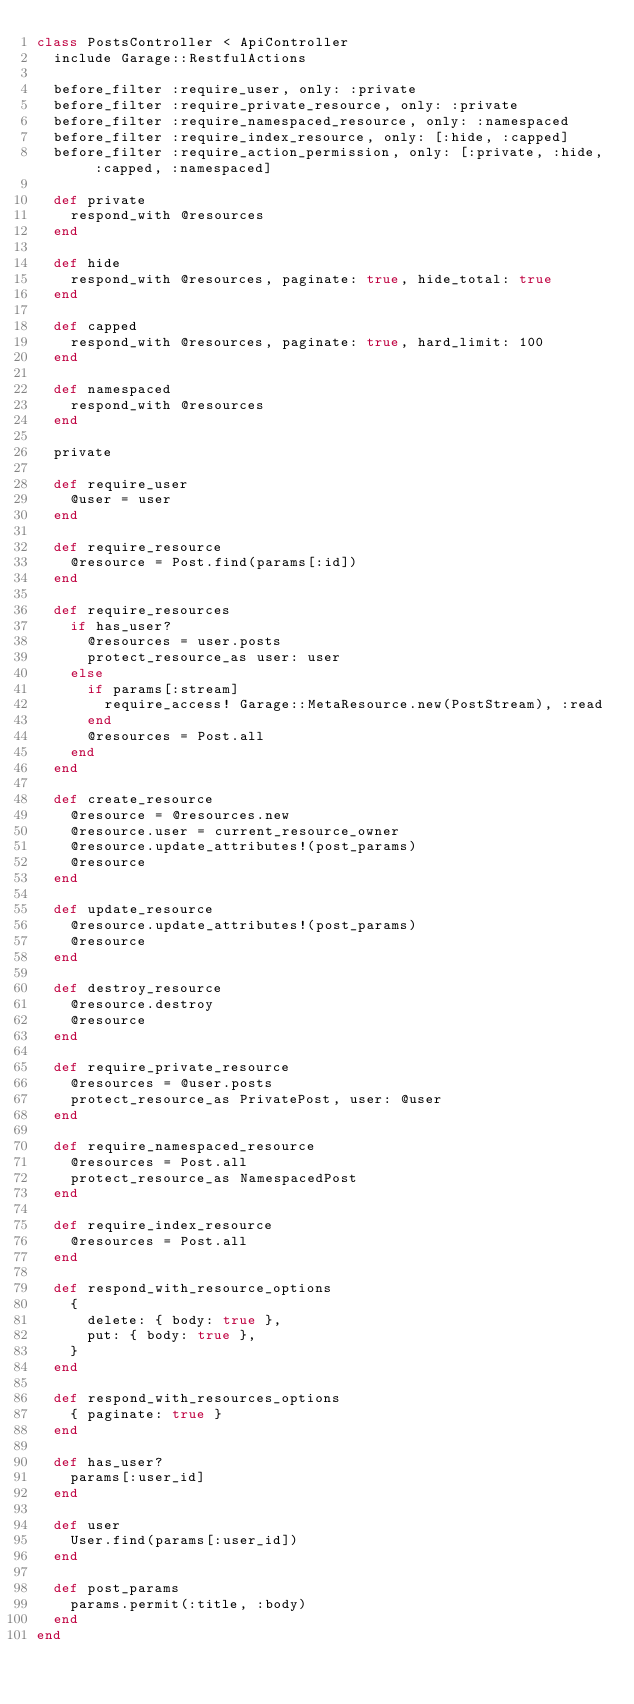Convert code to text. <code><loc_0><loc_0><loc_500><loc_500><_Ruby_>class PostsController < ApiController
  include Garage::RestfulActions

  before_filter :require_user, only: :private
  before_filter :require_private_resource, only: :private
  before_filter :require_namespaced_resource, only: :namespaced
  before_filter :require_index_resource, only: [:hide, :capped]
  before_filter :require_action_permission, only: [:private, :hide, :capped, :namespaced]

  def private
    respond_with @resources
  end

  def hide
    respond_with @resources, paginate: true, hide_total: true
  end

  def capped
    respond_with @resources, paginate: true, hard_limit: 100
  end

  def namespaced
    respond_with @resources
  end

  private

  def require_user
    @user = user
  end

  def require_resource
    @resource = Post.find(params[:id])
  end

  def require_resources
    if has_user?
      @resources = user.posts
      protect_resource_as user: user
    else
      if params[:stream]
        require_access! Garage::MetaResource.new(PostStream), :read
      end
      @resources = Post.all
    end
  end

  def create_resource
    @resource = @resources.new
    @resource.user = current_resource_owner
    @resource.update_attributes!(post_params)
    @resource
  end

  def update_resource
    @resource.update_attributes!(post_params)
    @resource
  end

  def destroy_resource
    @resource.destroy
    @resource
  end

  def require_private_resource
    @resources = @user.posts
    protect_resource_as PrivatePost, user: @user
  end

  def require_namespaced_resource
    @resources = Post.all
    protect_resource_as NamespacedPost
  end

  def require_index_resource
    @resources = Post.all
  end

  def respond_with_resource_options
    {
      delete: { body: true },
      put: { body: true },
    }
  end

  def respond_with_resources_options
    { paginate: true }
  end

  def has_user?
    params[:user_id]
  end

  def user
    User.find(params[:user_id])
  end

  def post_params
    params.permit(:title, :body)
  end
end
</code> 